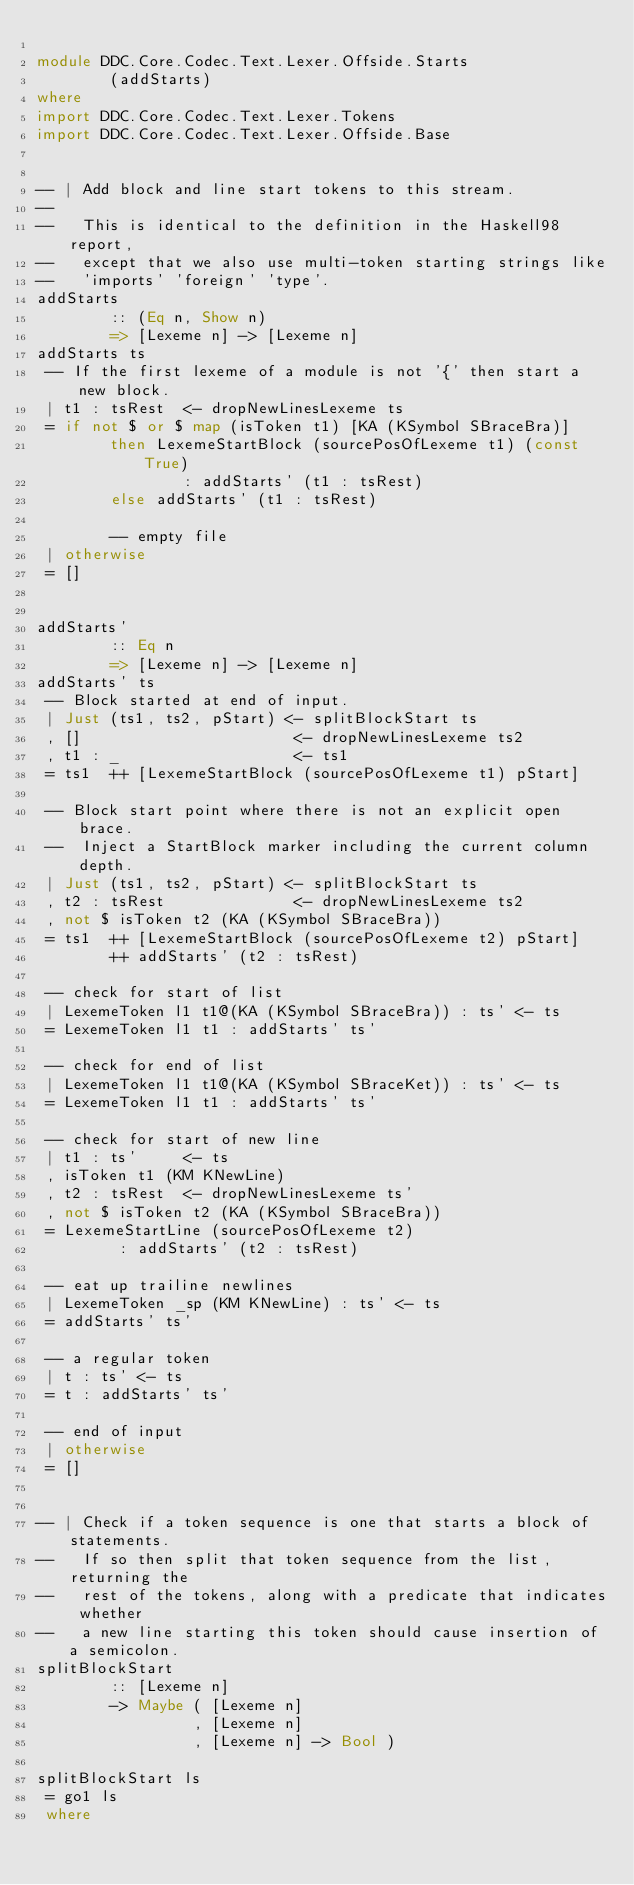Convert code to text. <code><loc_0><loc_0><loc_500><loc_500><_Haskell_>
module DDC.Core.Codec.Text.Lexer.Offside.Starts
        (addStarts)
where
import DDC.Core.Codec.Text.Lexer.Tokens
import DDC.Core.Codec.Text.Lexer.Offside.Base


-- | Add block and line start tokens to this stream.
--
--   This is identical to the definition in the Haskell98 report,
--   except that we also use multi-token starting strings like
--   'imports' 'foreign' 'type'.
addStarts
        :: (Eq n, Show n)
        => [Lexeme n] -> [Lexeme n]
addStarts ts
 -- If the first lexeme of a module is not '{' then start a new block.
 | t1 : tsRest  <- dropNewLinesLexeme ts
 = if not $ or $ map (isToken t1) [KA (KSymbol SBraceBra)]
        then LexemeStartBlock (sourcePosOfLexeme t1) (const True)
                : addStarts' (t1 : tsRest)
        else addStarts' (t1 : tsRest)

        -- empty file
 | otherwise
 = []


addStarts'
        :: Eq n
        => [Lexeme n] -> [Lexeme n]
addStarts' ts
 -- Block started at end of input.
 | Just (ts1, ts2, pStart) <- splitBlockStart ts
 , []                       <- dropNewLinesLexeme ts2
 , t1 : _                   <- ts1
 = ts1  ++ [LexemeStartBlock (sourcePosOfLexeme t1) pStart]

 -- Block start point where there is not an explicit open brace.
 --  Inject a StartBlock marker including the current column depth.
 | Just (ts1, ts2, pStart) <- splitBlockStart ts
 , t2 : tsRest              <- dropNewLinesLexeme ts2
 , not $ isToken t2 (KA (KSymbol SBraceBra))
 = ts1  ++ [LexemeStartBlock (sourcePosOfLexeme t2) pStart]
        ++ addStarts' (t2 : tsRest)

 -- check for start of list
 | LexemeToken l1 t1@(KA (KSymbol SBraceBra)) : ts' <- ts
 = LexemeToken l1 t1 : addStarts' ts'

 -- check for end of list
 | LexemeToken l1 t1@(KA (KSymbol SBraceKet)) : ts' <- ts
 = LexemeToken l1 t1 : addStarts' ts'

 -- check for start of new line
 | t1 : ts'     <- ts
 , isToken t1 (KM KNewLine)
 , t2 : tsRest  <- dropNewLinesLexeme ts'
 , not $ isToken t2 (KA (KSymbol SBraceBra))
 = LexemeStartLine (sourcePosOfLexeme t2)
         : addStarts' (t2 : tsRest)

 -- eat up trailine newlines
 | LexemeToken _sp (KM KNewLine) : ts' <- ts
 = addStarts' ts'

 -- a regular token
 | t : ts' <- ts
 = t : addStarts' ts'

 -- end of input
 | otherwise
 = []


-- | Check if a token sequence is one that starts a block of statements.
--   If so then split that token sequence from the list, returning the
--   rest of the tokens, along with a predicate that indicates whether
--   a new line starting this token should cause insertion of a semicolon.
splitBlockStart
        :: [Lexeme n]
        -> Maybe ( [Lexeme n]
                 , [Lexeme n]
                 , [Lexeme n] -> Bool )

splitBlockStart ls
 = go1 ls
 where</code> 